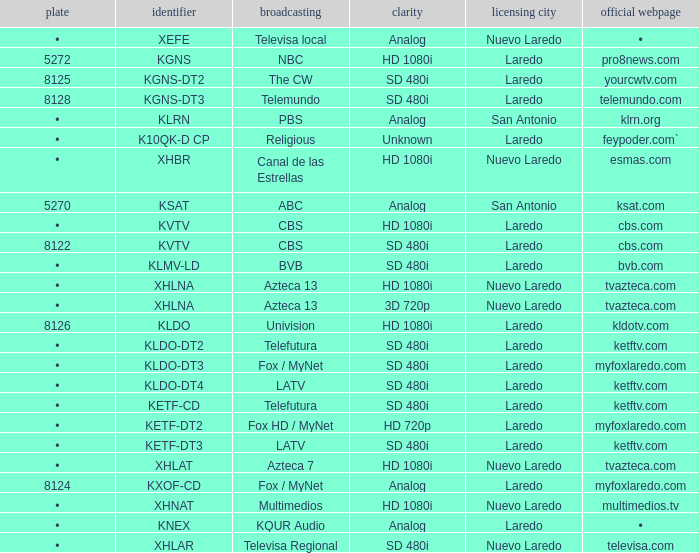Identify the official website with a • dish and the kvtz callsign. Cbs.com. Would you be able to parse every entry in this table? {'header': ['plate', 'identifier', 'broadcasting', 'clarity', 'licensing city', 'official webpage'], 'rows': [['•', 'XEFE', 'Televisa local', 'Analog', 'Nuevo Laredo', '•'], ['5272', 'KGNS', 'NBC', 'HD 1080i', 'Laredo', 'pro8news.com'], ['8125', 'KGNS-DT2', 'The CW', 'SD 480i', 'Laredo', 'yourcwtv.com'], ['8128', 'KGNS-DT3', 'Telemundo', 'SD 480i', 'Laredo', 'telemundo.com'], ['•', 'KLRN', 'PBS', 'Analog', 'San Antonio', 'klrn.org'], ['•', 'K10QK-D CP', 'Religious', 'Unknown', 'Laredo', 'feypoder.com`'], ['•', 'XHBR', 'Canal de las Estrellas', 'HD 1080i', 'Nuevo Laredo', 'esmas.com'], ['5270', 'KSAT', 'ABC', 'Analog', 'San Antonio', 'ksat.com'], ['•', 'KVTV', 'CBS', 'HD 1080i', 'Laredo', 'cbs.com'], ['8122', 'KVTV', 'CBS', 'SD 480i', 'Laredo', 'cbs.com'], ['•', 'KLMV-LD', 'BVB', 'SD 480i', 'Laredo', 'bvb.com'], ['•', 'XHLNA', 'Azteca 13', 'HD 1080i', 'Nuevo Laredo', 'tvazteca.com'], ['•', 'XHLNA', 'Azteca 13', '3D 720p', 'Nuevo Laredo', 'tvazteca.com'], ['8126', 'KLDO', 'Univision', 'HD 1080i', 'Laredo', 'kldotv.com'], ['•', 'KLDO-DT2', 'Telefutura', 'SD 480i', 'Laredo', 'ketftv.com'], ['•', 'KLDO-DT3', 'Fox / MyNet', 'SD 480i', 'Laredo', 'myfoxlaredo.com'], ['•', 'KLDO-DT4', 'LATV', 'SD 480i', 'Laredo', 'ketftv.com'], ['•', 'KETF-CD', 'Telefutura', 'SD 480i', 'Laredo', 'ketftv.com'], ['•', 'KETF-DT2', 'Fox HD / MyNet', 'HD 720p', 'Laredo', 'myfoxlaredo.com'], ['•', 'KETF-DT3', 'LATV', 'SD 480i', 'Laredo', 'ketftv.com'], ['•', 'XHLAT', 'Azteca 7', 'HD 1080i', 'Nuevo Laredo', 'tvazteca.com'], ['8124', 'KXOF-CD', 'Fox / MyNet', 'Analog', 'Laredo', 'myfoxlaredo.com'], ['•', 'XHNAT', 'Multimedios', 'HD 1080i', 'Nuevo Laredo', 'multimedios.tv'], ['•', 'KNEX', 'KQUR Audio', 'Analog', 'Laredo', '•'], ['•', 'XHLAR', 'Televisa Regional', 'SD 480i', 'Nuevo Laredo', 'televisa.com']]} 